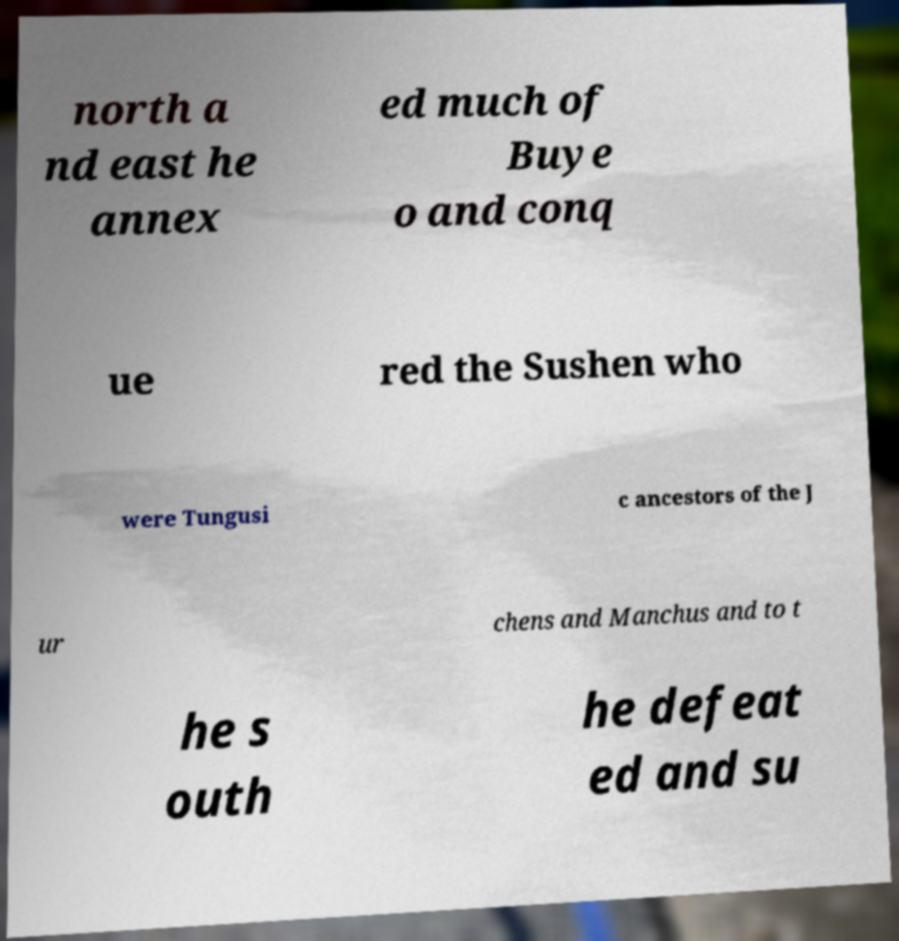Could you extract and type out the text from this image? north a nd east he annex ed much of Buye o and conq ue red the Sushen who were Tungusi c ancestors of the J ur chens and Manchus and to t he s outh he defeat ed and su 